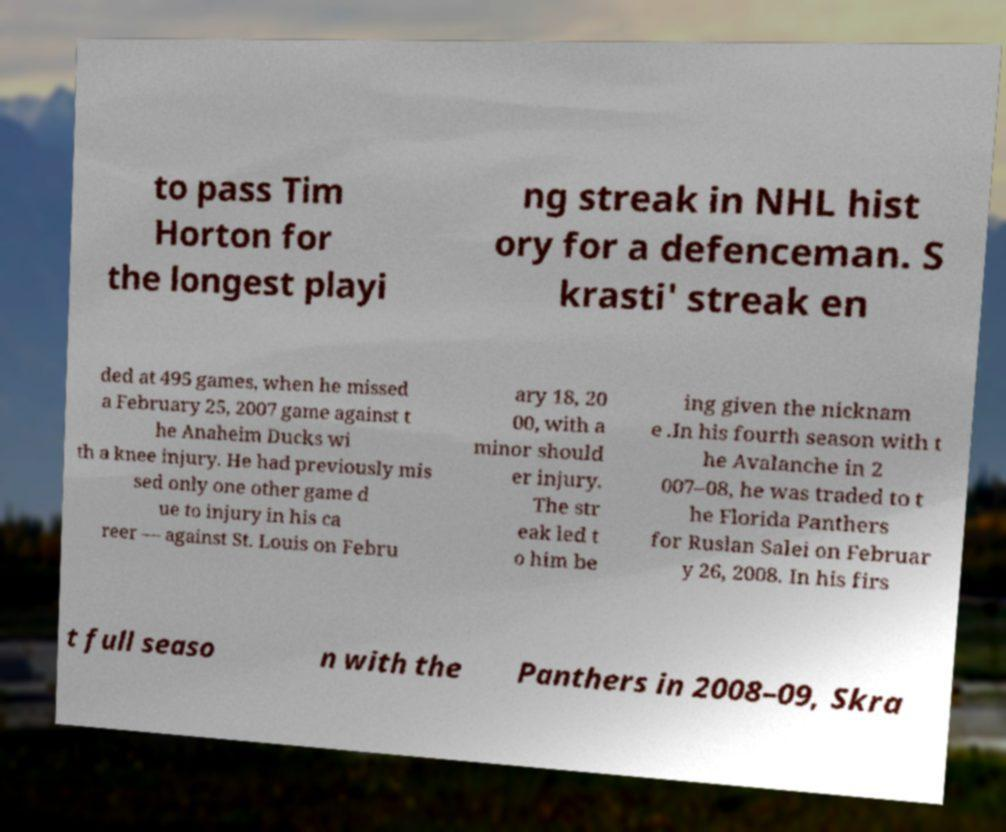What messages or text are displayed in this image? I need them in a readable, typed format. to pass Tim Horton for the longest playi ng streak in NHL hist ory for a defenceman. S krasti' streak en ded at 495 games, when he missed a February 25, 2007 game against t he Anaheim Ducks wi th a knee injury. He had previously mis sed only one other game d ue to injury in his ca reer — against St. Louis on Febru ary 18, 20 00, with a minor should er injury. The str eak led t o him be ing given the nicknam e .In his fourth season with t he Avalanche in 2 007–08, he was traded to t he Florida Panthers for Ruslan Salei on Februar y 26, 2008. In his firs t full seaso n with the Panthers in 2008–09, Skra 